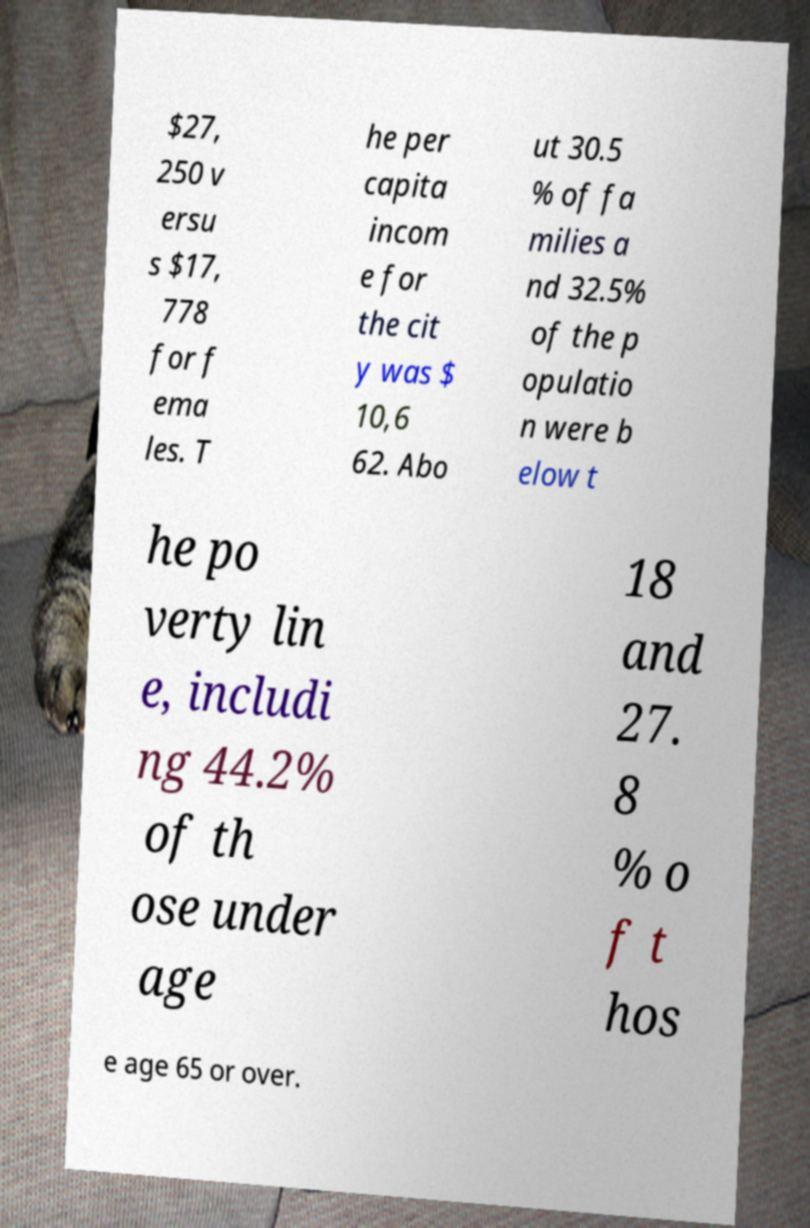Please read and relay the text visible in this image. What does it say? $27, 250 v ersu s $17, 778 for f ema les. T he per capita incom e for the cit y was $ 10,6 62. Abo ut 30.5 % of fa milies a nd 32.5% of the p opulatio n were b elow t he po verty lin e, includi ng 44.2% of th ose under age 18 and 27. 8 % o f t hos e age 65 or over. 